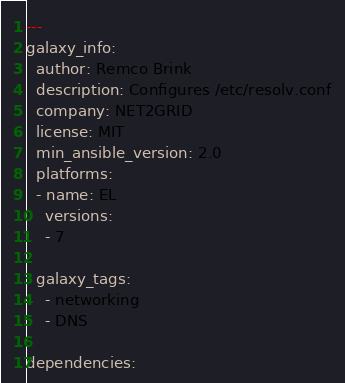Convert code to text. <code><loc_0><loc_0><loc_500><loc_500><_YAML_>---
galaxy_info:
  author: Remco Brink
  description: Configures /etc/resolv.conf
  company: NET2GRID
  license: MIT
  min_ansible_version: 2.0
  platforms:
  - name: EL
    versions:
    - 7

  galaxy_tags:
    - networking
    - DNS

dependencies:
</code> 